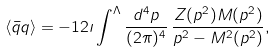<formula> <loc_0><loc_0><loc_500><loc_500>\left \langle \bar { q } q \right \rangle = - 1 2 \imath \int ^ { \Lambda } \frac { d ^ { 4 } p } { ( 2 \pi ) ^ { 4 } } \, \frac { Z ( p ^ { 2 } ) M ( p ^ { 2 } ) } { p ^ { 2 } - M ^ { 2 } ( p ^ { 2 } ) } ,</formula> 